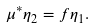<formula> <loc_0><loc_0><loc_500><loc_500>\mu ^ { * } \eta _ { 2 } = f \eta _ { 1 } .</formula> 